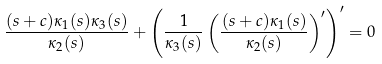<formula> <loc_0><loc_0><loc_500><loc_500>\frac { ( s + c ) \kappa _ { 1 } ( s ) \kappa _ { 3 } ( s ) } { \kappa _ { 2 } ( s ) } + \left ( \frac { 1 } { \kappa _ { 3 } ( s ) } \left ( \frac { ( s + c ) \kappa _ { 1 } ( s ) } { \kappa _ { 2 } ( s ) } \right ) ^ { \prime } \right ) ^ { \prime } = 0</formula> 